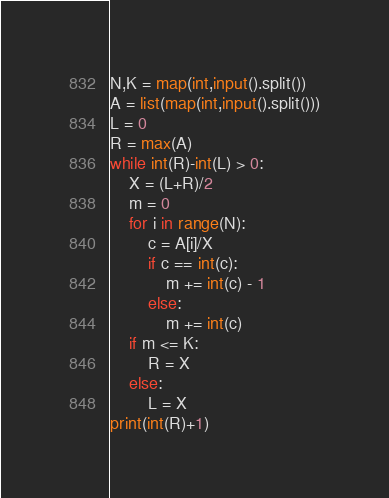Convert code to text. <code><loc_0><loc_0><loc_500><loc_500><_Python_>N,K = map(int,input().split())
A = list(map(int,input().split()))
L = 0
R = max(A)
while int(R)-int(L) > 0:
    X = (L+R)/2
    m = 0
    for i in range(N):
        c = A[i]/X
        if c == int(c):
            m += int(c) - 1
        else:
            m += int(c)
    if m <= K:
        R = X
    else:
        L = X
print(int(R)+1)
</code> 